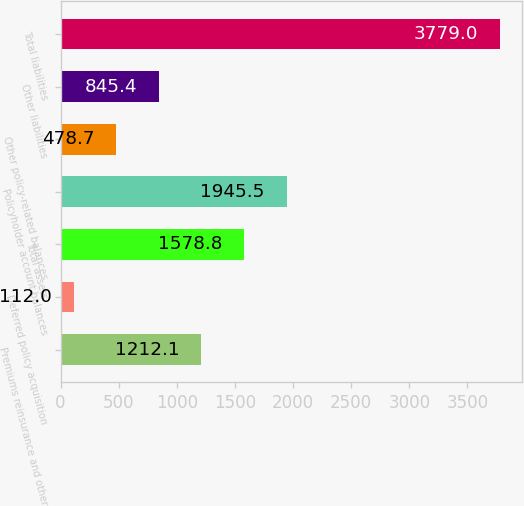Convert chart to OTSL. <chart><loc_0><loc_0><loc_500><loc_500><bar_chart><fcel>Premiums reinsurance and other<fcel>Deferred policy acquisition<fcel>Total assets<fcel>Policyholder account balances<fcel>Other policy-related balances<fcel>Other liabilities<fcel>Total liabilities<nl><fcel>1212.1<fcel>112<fcel>1578.8<fcel>1945.5<fcel>478.7<fcel>845.4<fcel>3779<nl></chart> 